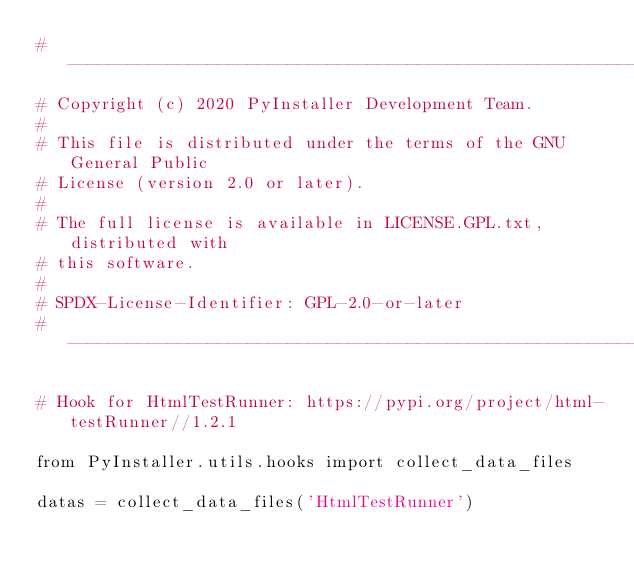<code> <loc_0><loc_0><loc_500><loc_500><_Python_># ------------------------------------------------------------------
# Copyright (c) 2020 PyInstaller Development Team.
#
# This file is distributed under the terms of the GNU General Public
# License (version 2.0 or later).
#
# The full license is available in LICENSE.GPL.txt, distributed with
# this software.
#
# SPDX-License-Identifier: GPL-2.0-or-later
# ------------------------------------------------------------------

# Hook for HtmlTestRunner: https://pypi.org/project/html-testRunner//1.2.1

from PyInstaller.utils.hooks import collect_data_files

datas = collect_data_files('HtmlTestRunner')
</code> 